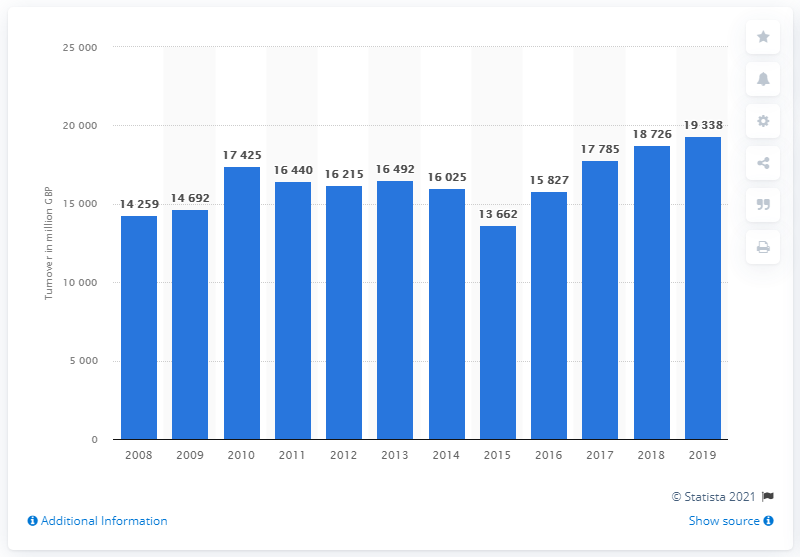Outline some significant characteristics in this image. In the United Kingdom in 2019, the retail sales of automotive fuel from specialized stores was 193,380. In the year prior, the turnover of stores specializing in automotive fuel was 18,726. 